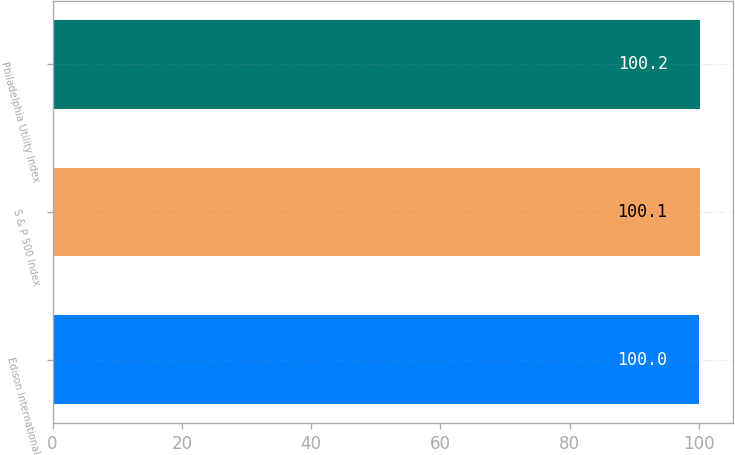Convert chart. <chart><loc_0><loc_0><loc_500><loc_500><bar_chart><fcel>Edison International<fcel>S & P 500 Index<fcel>Philadelphia Utility Index<nl><fcel>100<fcel>100.1<fcel>100.2<nl></chart> 